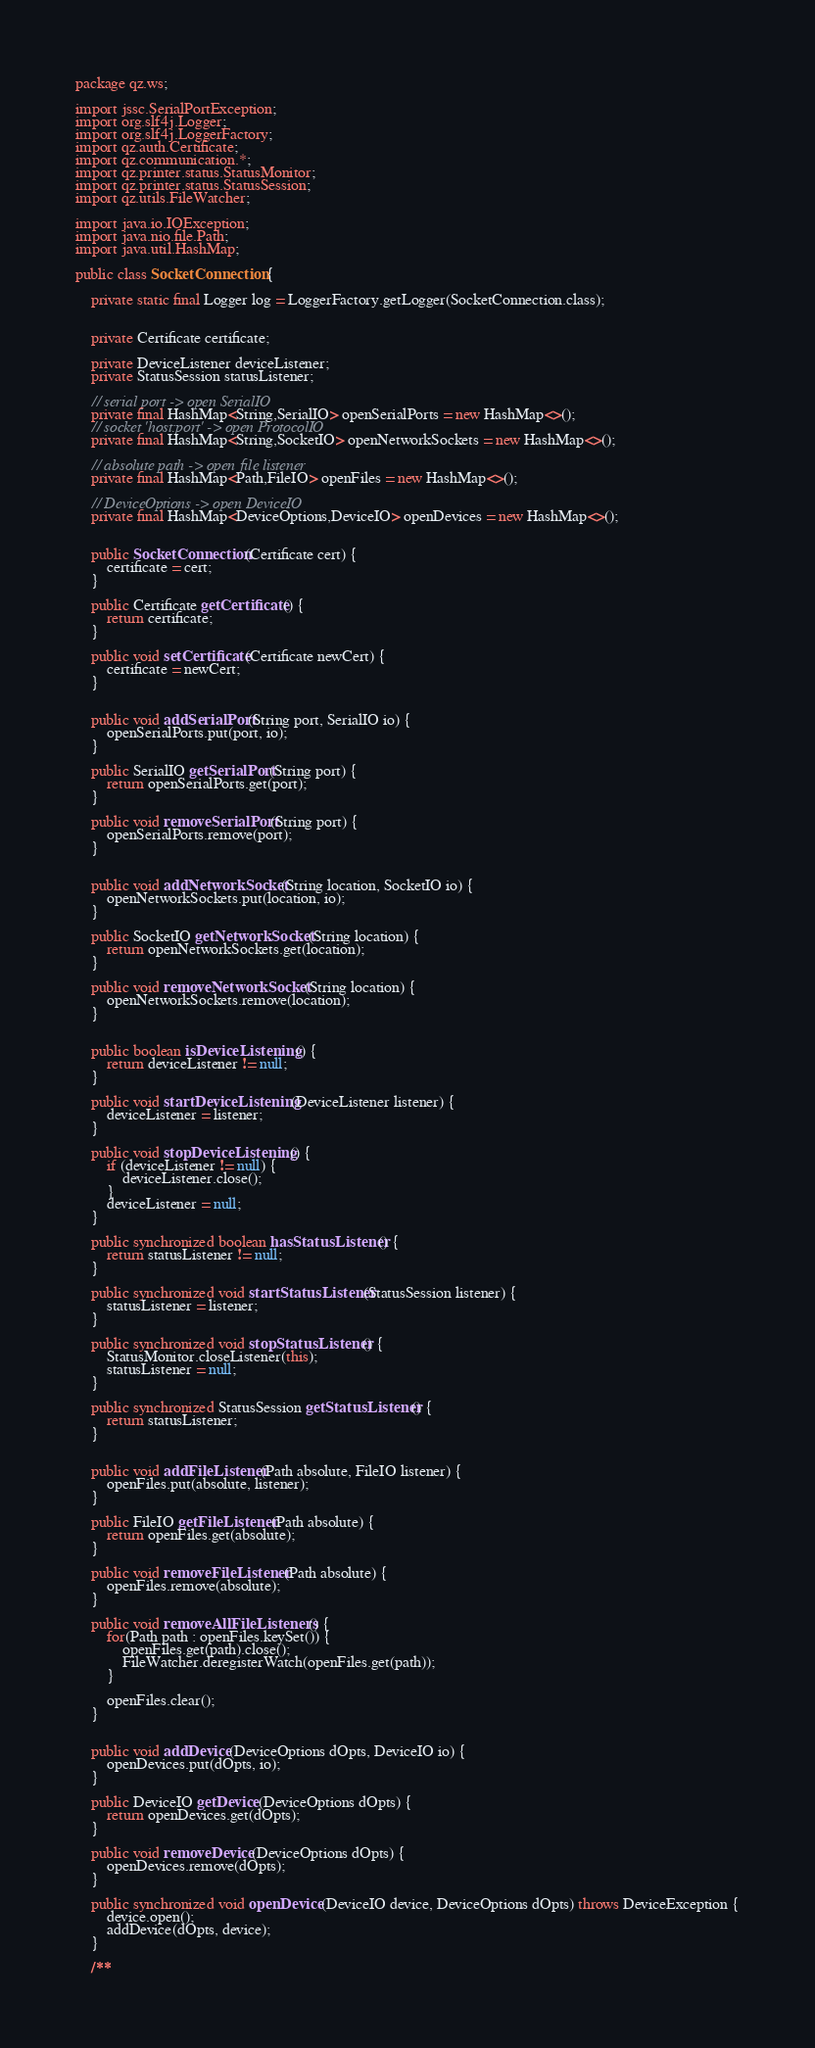<code> <loc_0><loc_0><loc_500><loc_500><_Java_>package qz.ws;

import jssc.SerialPortException;
import org.slf4j.Logger;
import org.slf4j.LoggerFactory;
import qz.auth.Certificate;
import qz.communication.*;
import qz.printer.status.StatusMonitor;
import qz.printer.status.StatusSession;
import qz.utils.FileWatcher;

import java.io.IOException;
import java.nio.file.Path;
import java.util.HashMap;

public class SocketConnection {

    private static final Logger log = LoggerFactory.getLogger(SocketConnection.class);


    private Certificate certificate;

    private DeviceListener deviceListener;
    private StatusSession statusListener;

    // serial port -> open SerialIO
    private final HashMap<String,SerialIO> openSerialPorts = new HashMap<>();
    // socket 'host:port' -> open ProtocolIO
    private final HashMap<String,SocketIO> openNetworkSockets = new HashMap<>();

    // absolute path -> open file listener
    private final HashMap<Path,FileIO> openFiles = new HashMap<>();

    // DeviceOptions -> open DeviceIO
    private final HashMap<DeviceOptions,DeviceIO> openDevices = new HashMap<>();


    public SocketConnection(Certificate cert) {
        certificate = cert;
    }

    public Certificate getCertificate() {
        return certificate;
    }

    public void setCertificate(Certificate newCert) {
        certificate = newCert;
    }


    public void addSerialPort(String port, SerialIO io) {
        openSerialPorts.put(port, io);
    }

    public SerialIO getSerialPort(String port) {
        return openSerialPorts.get(port);
    }

    public void removeSerialPort(String port) {
        openSerialPorts.remove(port);
    }


    public void addNetworkSocket(String location, SocketIO io) {
        openNetworkSockets.put(location, io);
    }

    public SocketIO getNetworkSocket(String location) {
        return openNetworkSockets.get(location);
    }

    public void removeNetworkSocket(String location) {
        openNetworkSockets.remove(location);
    }


    public boolean isDeviceListening() {
        return deviceListener != null;
    }

    public void startDeviceListening(DeviceListener listener) {
        deviceListener = listener;
    }

    public void stopDeviceListening() {
        if (deviceListener != null) {
            deviceListener.close();
        }
        deviceListener = null;
    }

    public synchronized boolean hasStatusListener() {
        return statusListener != null;
    }

    public synchronized void startStatusListener(StatusSession listener) {
        statusListener = listener;
    }

    public synchronized void stopStatusListener() {
        StatusMonitor.closeListener(this);
        statusListener = null;
    }

    public synchronized StatusSession getStatusListener() {
        return statusListener;
    }


    public void addFileListener(Path absolute, FileIO listener) {
        openFiles.put(absolute, listener);
    }

    public FileIO getFileListener(Path absolute) {
        return openFiles.get(absolute);
    }

    public void removeFileListener(Path absolute) {
        openFiles.remove(absolute);
    }

    public void removeAllFileListeners() {
        for(Path path : openFiles.keySet()) {
            openFiles.get(path).close();
            FileWatcher.deregisterWatch(openFiles.get(path));
        }

        openFiles.clear();
    }


    public void addDevice(DeviceOptions dOpts, DeviceIO io) {
        openDevices.put(dOpts, io);
    }

    public DeviceIO getDevice(DeviceOptions dOpts) {
        return openDevices.get(dOpts);
    }

    public void removeDevice(DeviceOptions dOpts) {
        openDevices.remove(dOpts);
    }

    public synchronized void openDevice(DeviceIO device, DeviceOptions dOpts) throws DeviceException {
        device.open();
        addDevice(dOpts, device);
    }

    /**</code> 